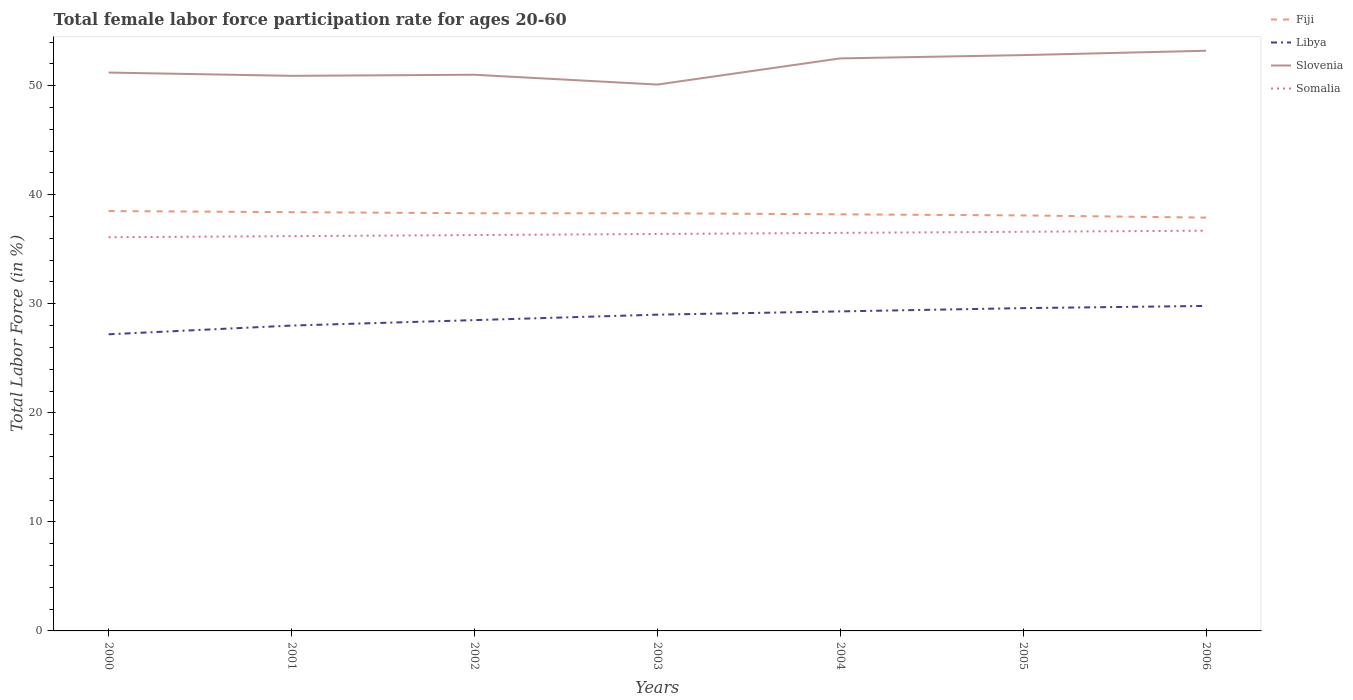How many different coloured lines are there?
Your answer should be compact. 4. Is the number of lines equal to the number of legend labels?
Make the answer very short. Yes. Across all years, what is the maximum female labor force participation rate in Slovenia?
Keep it short and to the point. 50.1. What is the total female labor force participation rate in Libya in the graph?
Give a very brief answer. -1.1. What is the difference between the highest and the second highest female labor force participation rate in Slovenia?
Give a very brief answer. 3.1. What is the difference between the highest and the lowest female labor force participation rate in Slovenia?
Give a very brief answer. 3. Is the female labor force participation rate in Fiji strictly greater than the female labor force participation rate in Somalia over the years?
Your answer should be compact. No. How many lines are there?
Make the answer very short. 4. What is the difference between two consecutive major ticks on the Y-axis?
Offer a very short reply. 10. Are the values on the major ticks of Y-axis written in scientific E-notation?
Your answer should be very brief. No. Does the graph contain any zero values?
Your response must be concise. No. Does the graph contain grids?
Make the answer very short. No. Where does the legend appear in the graph?
Your answer should be very brief. Top right. How are the legend labels stacked?
Give a very brief answer. Vertical. What is the title of the graph?
Give a very brief answer. Total female labor force participation rate for ages 20-60. Does "Aruba" appear as one of the legend labels in the graph?
Your answer should be compact. No. What is the label or title of the Y-axis?
Your answer should be compact. Total Labor Force (in %). What is the Total Labor Force (in %) of Fiji in 2000?
Offer a terse response. 38.5. What is the Total Labor Force (in %) of Libya in 2000?
Keep it short and to the point. 27.2. What is the Total Labor Force (in %) of Slovenia in 2000?
Ensure brevity in your answer.  51.2. What is the Total Labor Force (in %) in Somalia in 2000?
Your response must be concise. 36.1. What is the Total Labor Force (in %) in Fiji in 2001?
Offer a very short reply. 38.4. What is the Total Labor Force (in %) of Libya in 2001?
Offer a terse response. 28. What is the Total Labor Force (in %) in Slovenia in 2001?
Give a very brief answer. 50.9. What is the Total Labor Force (in %) of Somalia in 2001?
Your response must be concise. 36.2. What is the Total Labor Force (in %) of Fiji in 2002?
Keep it short and to the point. 38.3. What is the Total Labor Force (in %) in Libya in 2002?
Ensure brevity in your answer.  28.5. What is the Total Labor Force (in %) in Slovenia in 2002?
Your answer should be very brief. 51. What is the Total Labor Force (in %) in Somalia in 2002?
Ensure brevity in your answer.  36.3. What is the Total Labor Force (in %) of Fiji in 2003?
Ensure brevity in your answer.  38.3. What is the Total Labor Force (in %) of Slovenia in 2003?
Ensure brevity in your answer.  50.1. What is the Total Labor Force (in %) in Somalia in 2003?
Give a very brief answer. 36.4. What is the Total Labor Force (in %) in Fiji in 2004?
Make the answer very short. 38.2. What is the Total Labor Force (in %) in Libya in 2004?
Your answer should be compact. 29.3. What is the Total Labor Force (in %) of Slovenia in 2004?
Make the answer very short. 52.5. What is the Total Labor Force (in %) in Somalia in 2004?
Make the answer very short. 36.5. What is the Total Labor Force (in %) of Fiji in 2005?
Your answer should be compact. 38.1. What is the Total Labor Force (in %) of Libya in 2005?
Provide a succinct answer. 29.6. What is the Total Labor Force (in %) of Slovenia in 2005?
Keep it short and to the point. 52.8. What is the Total Labor Force (in %) in Somalia in 2005?
Your response must be concise. 36.6. What is the Total Labor Force (in %) in Fiji in 2006?
Keep it short and to the point. 37.9. What is the Total Labor Force (in %) of Libya in 2006?
Keep it short and to the point. 29.8. What is the Total Labor Force (in %) of Slovenia in 2006?
Your response must be concise. 53.2. What is the Total Labor Force (in %) in Somalia in 2006?
Keep it short and to the point. 36.7. Across all years, what is the maximum Total Labor Force (in %) of Fiji?
Provide a short and direct response. 38.5. Across all years, what is the maximum Total Labor Force (in %) in Libya?
Provide a short and direct response. 29.8. Across all years, what is the maximum Total Labor Force (in %) in Slovenia?
Provide a short and direct response. 53.2. Across all years, what is the maximum Total Labor Force (in %) in Somalia?
Keep it short and to the point. 36.7. Across all years, what is the minimum Total Labor Force (in %) of Fiji?
Your answer should be compact. 37.9. Across all years, what is the minimum Total Labor Force (in %) of Libya?
Give a very brief answer. 27.2. Across all years, what is the minimum Total Labor Force (in %) of Slovenia?
Make the answer very short. 50.1. Across all years, what is the minimum Total Labor Force (in %) of Somalia?
Your response must be concise. 36.1. What is the total Total Labor Force (in %) in Fiji in the graph?
Provide a succinct answer. 267.7. What is the total Total Labor Force (in %) in Libya in the graph?
Keep it short and to the point. 201.4. What is the total Total Labor Force (in %) in Slovenia in the graph?
Offer a very short reply. 361.7. What is the total Total Labor Force (in %) in Somalia in the graph?
Keep it short and to the point. 254.8. What is the difference between the Total Labor Force (in %) of Fiji in 2000 and that in 2002?
Provide a succinct answer. 0.2. What is the difference between the Total Labor Force (in %) of Libya in 2000 and that in 2002?
Your answer should be compact. -1.3. What is the difference between the Total Labor Force (in %) of Slovenia in 2000 and that in 2002?
Keep it short and to the point. 0.2. What is the difference between the Total Labor Force (in %) in Fiji in 2000 and that in 2004?
Make the answer very short. 0.3. What is the difference between the Total Labor Force (in %) in Somalia in 2000 and that in 2004?
Ensure brevity in your answer.  -0.4. What is the difference between the Total Labor Force (in %) of Fiji in 2000 and that in 2006?
Give a very brief answer. 0.6. What is the difference between the Total Labor Force (in %) of Slovenia in 2000 and that in 2006?
Ensure brevity in your answer.  -2. What is the difference between the Total Labor Force (in %) in Somalia in 2000 and that in 2006?
Offer a very short reply. -0.6. What is the difference between the Total Labor Force (in %) of Libya in 2001 and that in 2002?
Your answer should be compact. -0.5. What is the difference between the Total Labor Force (in %) in Slovenia in 2001 and that in 2002?
Make the answer very short. -0.1. What is the difference between the Total Labor Force (in %) in Somalia in 2001 and that in 2002?
Your answer should be very brief. -0.1. What is the difference between the Total Labor Force (in %) of Libya in 2001 and that in 2003?
Provide a short and direct response. -1. What is the difference between the Total Labor Force (in %) of Fiji in 2001 and that in 2004?
Your answer should be compact. 0.2. What is the difference between the Total Labor Force (in %) of Slovenia in 2001 and that in 2004?
Your response must be concise. -1.6. What is the difference between the Total Labor Force (in %) of Fiji in 2001 and that in 2005?
Offer a terse response. 0.3. What is the difference between the Total Labor Force (in %) of Libya in 2001 and that in 2005?
Your answer should be compact. -1.6. What is the difference between the Total Labor Force (in %) of Fiji in 2001 and that in 2006?
Your answer should be very brief. 0.5. What is the difference between the Total Labor Force (in %) of Libya in 2001 and that in 2006?
Give a very brief answer. -1.8. What is the difference between the Total Labor Force (in %) of Slovenia in 2001 and that in 2006?
Ensure brevity in your answer.  -2.3. What is the difference between the Total Labor Force (in %) of Fiji in 2002 and that in 2003?
Your answer should be compact. 0. What is the difference between the Total Labor Force (in %) in Slovenia in 2002 and that in 2003?
Ensure brevity in your answer.  0.9. What is the difference between the Total Labor Force (in %) of Somalia in 2002 and that in 2003?
Your answer should be compact. -0.1. What is the difference between the Total Labor Force (in %) in Fiji in 2002 and that in 2004?
Ensure brevity in your answer.  0.1. What is the difference between the Total Labor Force (in %) in Slovenia in 2002 and that in 2004?
Offer a terse response. -1.5. What is the difference between the Total Labor Force (in %) of Libya in 2002 and that in 2005?
Provide a succinct answer. -1.1. What is the difference between the Total Labor Force (in %) of Somalia in 2002 and that in 2005?
Provide a succinct answer. -0.3. What is the difference between the Total Labor Force (in %) in Fiji in 2002 and that in 2006?
Give a very brief answer. 0.4. What is the difference between the Total Labor Force (in %) in Libya in 2002 and that in 2006?
Provide a short and direct response. -1.3. What is the difference between the Total Labor Force (in %) in Somalia in 2002 and that in 2006?
Offer a terse response. -0.4. What is the difference between the Total Labor Force (in %) of Fiji in 2003 and that in 2004?
Your answer should be compact. 0.1. What is the difference between the Total Labor Force (in %) in Libya in 2003 and that in 2004?
Your answer should be compact. -0.3. What is the difference between the Total Labor Force (in %) in Slovenia in 2003 and that in 2005?
Offer a terse response. -2.7. What is the difference between the Total Labor Force (in %) of Somalia in 2003 and that in 2005?
Keep it short and to the point. -0.2. What is the difference between the Total Labor Force (in %) of Fiji in 2003 and that in 2006?
Provide a succinct answer. 0.4. What is the difference between the Total Labor Force (in %) in Libya in 2003 and that in 2006?
Offer a terse response. -0.8. What is the difference between the Total Labor Force (in %) in Slovenia in 2003 and that in 2006?
Give a very brief answer. -3.1. What is the difference between the Total Labor Force (in %) in Fiji in 2004 and that in 2006?
Keep it short and to the point. 0.3. What is the difference between the Total Labor Force (in %) of Slovenia in 2004 and that in 2006?
Offer a very short reply. -0.7. What is the difference between the Total Labor Force (in %) in Somalia in 2004 and that in 2006?
Provide a short and direct response. -0.2. What is the difference between the Total Labor Force (in %) in Libya in 2005 and that in 2006?
Your answer should be very brief. -0.2. What is the difference between the Total Labor Force (in %) in Slovenia in 2005 and that in 2006?
Offer a very short reply. -0.4. What is the difference between the Total Labor Force (in %) in Fiji in 2000 and the Total Labor Force (in %) in Slovenia in 2001?
Keep it short and to the point. -12.4. What is the difference between the Total Labor Force (in %) in Libya in 2000 and the Total Labor Force (in %) in Slovenia in 2001?
Give a very brief answer. -23.7. What is the difference between the Total Labor Force (in %) of Fiji in 2000 and the Total Labor Force (in %) of Libya in 2002?
Your response must be concise. 10. What is the difference between the Total Labor Force (in %) in Fiji in 2000 and the Total Labor Force (in %) in Slovenia in 2002?
Ensure brevity in your answer.  -12.5. What is the difference between the Total Labor Force (in %) of Libya in 2000 and the Total Labor Force (in %) of Slovenia in 2002?
Offer a terse response. -23.8. What is the difference between the Total Labor Force (in %) of Libya in 2000 and the Total Labor Force (in %) of Somalia in 2002?
Your answer should be compact. -9.1. What is the difference between the Total Labor Force (in %) in Slovenia in 2000 and the Total Labor Force (in %) in Somalia in 2002?
Ensure brevity in your answer.  14.9. What is the difference between the Total Labor Force (in %) of Fiji in 2000 and the Total Labor Force (in %) of Libya in 2003?
Provide a short and direct response. 9.5. What is the difference between the Total Labor Force (in %) in Fiji in 2000 and the Total Labor Force (in %) in Slovenia in 2003?
Your answer should be very brief. -11.6. What is the difference between the Total Labor Force (in %) of Fiji in 2000 and the Total Labor Force (in %) of Somalia in 2003?
Make the answer very short. 2.1. What is the difference between the Total Labor Force (in %) of Libya in 2000 and the Total Labor Force (in %) of Slovenia in 2003?
Make the answer very short. -22.9. What is the difference between the Total Labor Force (in %) in Fiji in 2000 and the Total Labor Force (in %) in Libya in 2004?
Ensure brevity in your answer.  9.2. What is the difference between the Total Labor Force (in %) in Fiji in 2000 and the Total Labor Force (in %) in Somalia in 2004?
Ensure brevity in your answer.  2. What is the difference between the Total Labor Force (in %) of Libya in 2000 and the Total Labor Force (in %) of Slovenia in 2004?
Keep it short and to the point. -25.3. What is the difference between the Total Labor Force (in %) in Libya in 2000 and the Total Labor Force (in %) in Somalia in 2004?
Ensure brevity in your answer.  -9.3. What is the difference between the Total Labor Force (in %) in Fiji in 2000 and the Total Labor Force (in %) in Slovenia in 2005?
Keep it short and to the point. -14.3. What is the difference between the Total Labor Force (in %) in Fiji in 2000 and the Total Labor Force (in %) in Somalia in 2005?
Offer a very short reply. 1.9. What is the difference between the Total Labor Force (in %) in Libya in 2000 and the Total Labor Force (in %) in Slovenia in 2005?
Give a very brief answer. -25.6. What is the difference between the Total Labor Force (in %) in Libya in 2000 and the Total Labor Force (in %) in Somalia in 2005?
Ensure brevity in your answer.  -9.4. What is the difference between the Total Labor Force (in %) in Fiji in 2000 and the Total Labor Force (in %) in Libya in 2006?
Offer a terse response. 8.7. What is the difference between the Total Labor Force (in %) of Fiji in 2000 and the Total Labor Force (in %) of Slovenia in 2006?
Offer a terse response. -14.7. What is the difference between the Total Labor Force (in %) in Fiji in 2000 and the Total Labor Force (in %) in Somalia in 2006?
Make the answer very short. 1.8. What is the difference between the Total Labor Force (in %) in Slovenia in 2000 and the Total Labor Force (in %) in Somalia in 2006?
Offer a terse response. 14.5. What is the difference between the Total Labor Force (in %) in Fiji in 2001 and the Total Labor Force (in %) in Libya in 2002?
Your response must be concise. 9.9. What is the difference between the Total Labor Force (in %) of Fiji in 2001 and the Total Labor Force (in %) of Slovenia in 2002?
Give a very brief answer. -12.6. What is the difference between the Total Labor Force (in %) in Fiji in 2001 and the Total Labor Force (in %) in Somalia in 2002?
Your answer should be compact. 2.1. What is the difference between the Total Labor Force (in %) of Libya in 2001 and the Total Labor Force (in %) of Slovenia in 2002?
Offer a terse response. -23. What is the difference between the Total Labor Force (in %) in Libya in 2001 and the Total Labor Force (in %) in Somalia in 2002?
Ensure brevity in your answer.  -8.3. What is the difference between the Total Labor Force (in %) of Fiji in 2001 and the Total Labor Force (in %) of Slovenia in 2003?
Provide a succinct answer. -11.7. What is the difference between the Total Labor Force (in %) of Libya in 2001 and the Total Labor Force (in %) of Slovenia in 2003?
Your answer should be very brief. -22.1. What is the difference between the Total Labor Force (in %) in Fiji in 2001 and the Total Labor Force (in %) in Slovenia in 2004?
Provide a succinct answer. -14.1. What is the difference between the Total Labor Force (in %) of Libya in 2001 and the Total Labor Force (in %) of Slovenia in 2004?
Provide a succinct answer. -24.5. What is the difference between the Total Labor Force (in %) of Slovenia in 2001 and the Total Labor Force (in %) of Somalia in 2004?
Your answer should be very brief. 14.4. What is the difference between the Total Labor Force (in %) in Fiji in 2001 and the Total Labor Force (in %) in Slovenia in 2005?
Ensure brevity in your answer.  -14.4. What is the difference between the Total Labor Force (in %) of Fiji in 2001 and the Total Labor Force (in %) of Somalia in 2005?
Offer a terse response. 1.8. What is the difference between the Total Labor Force (in %) of Libya in 2001 and the Total Labor Force (in %) of Slovenia in 2005?
Your response must be concise. -24.8. What is the difference between the Total Labor Force (in %) in Libya in 2001 and the Total Labor Force (in %) in Somalia in 2005?
Provide a short and direct response. -8.6. What is the difference between the Total Labor Force (in %) in Fiji in 2001 and the Total Labor Force (in %) in Slovenia in 2006?
Your answer should be compact. -14.8. What is the difference between the Total Labor Force (in %) in Fiji in 2001 and the Total Labor Force (in %) in Somalia in 2006?
Keep it short and to the point. 1.7. What is the difference between the Total Labor Force (in %) in Libya in 2001 and the Total Labor Force (in %) in Slovenia in 2006?
Give a very brief answer. -25.2. What is the difference between the Total Labor Force (in %) in Slovenia in 2001 and the Total Labor Force (in %) in Somalia in 2006?
Ensure brevity in your answer.  14.2. What is the difference between the Total Labor Force (in %) in Fiji in 2002 and the Total Labor Force (in %) in Somalia in 2003?
Ensure brevity in your answer.  1.9. What is the difference between the Total Labor Force (in %) in Libya in 2002 and the Total Labor Force (in %) in Slovenia in 2003?
Provide a succinct answer. -21.6. What is the difference between the Total Labor Force (in %) in Fiji in 2002 and the Total Labor Force (in %) in Slovenia in 2004?
Your answer should be very brief. -14.2. What is the difference between the Total Labor Force (in %) in Slovenia in 2002 and the Total Labor Force (in %) in Somalia in 2004?
Provide a short and direct response. 14.5. What is the difference between the Total Labor Force (in %) in Fiji in 2002 and the Total Labor Force (in %) in Libya in 2005?
Your response must be concise. 8.7. What is the difference between the Total Labor Force (in %) in Fiji in 2002 and the Total Labor Force (in %) in Somalia in 2005?
Make the answer very short. 1.7. What is the difference between the Total Labor Force (in %) in Libya in 2002 and the Total Labor Force (in %) in Slovenia in 2005?
Offer a very short reply. -24.3. What is the difference between the Total Labor Force (in %) in Slovenia in 2002 and the Total Labor Force (in %) in Somalia in 2005?
Keep it short and to the point. 14.4. What is the difference between the Total Labor Force (in %) of Fiji in 2002 and the Total Labor Force (in %) of Libya in 2006?
Offer a very short reply. 8.5. What is the difference between the Total Labor Force (in %) in Fiji in 2002 and the Total Labor Force (in %) in Slovenia in 2006?
Your response must be concise. -14.9. What is the difference between the Total Labor Force (in %) of Fiji in 2002 and the Total Labor Force (in %) of Somalia in 2006?
Your answer should be compact. 1.6. What is the difference between the Total Labor Force (in %) in Libya in 2002 and the Total Labor Force (in %) in Slovenia in 2006?
Your answer should be very brief. -24.7. What is the difference between the Total Labor Force (in %) of Libya in 2002 and the Total Labor Force (in %) of Somalia in 2006?
Provide a succinct answer. -8.2. What is the difference between the Total Labor Force (in %) in Fiji in 2003 and the Total Labor Force (in %) in Libya in 2004?
Your answer should be compact. 9. What is the difference between the Total Labor Force (in %) in Fiji in 2003 and the Total Labor Force (in %) in Slovenia in 2004?
Provide a succinct answer. -14.2. What is the difference between the Total Labor Force (in %) of Libya in 2003 and the Total Labor Force (in %) of Slovenia in 2004?
Provide a short and direct response. -23.5. What is the difference between the Total Labor Force (in %) in Slovenia in 2003 and the Total Labor Force (in %) in Somalia in 2004?
Your answer should be compact. 13.6. What is the difference between the Total Labor Force (in %) in Fiji in 2003 and the Total Labor Force (in %) in Slovenia in 2005?
Your answer should be compact. -14.5. What is the difference between the Total Labor Force (in %) of Fiji in 2003 and the Total Labor Force (in %) of Somalia in 2005?
Your answer should be compact. 1.7. What is the difference between the Total Labor Force (in %) in Libya in 2003 and the Total Labor Force (in %) in Slovenia in 2005?
Provide a short and direct response. -23.8. What is the difference between the Total Labor Force (in %) in Libya in 2003 and the Total Labor Force (in %) in Somalia in 2005?
Offer a very short reply. -7.6. What is the difference between the Total Labor Force (in %) in Slovenia in 2003 and the Total Labor Force (in %) in Somalia in 2005?
Provide a succinct answer. 13.5. What is the difference between the Total Labor Force (in %) in Fiji in 2003 and the Total Labor Force (in %) in Libya in 2006?
Your answer should be compact. 8.5. What is the difference between the Total Labor Force (in %) in Fiji in 2003 and the Total Labor Force (in %) in Slovenia in 2006?
Provide a succinct answer. -14.9. What is the difference between the Total Labor Force (in %) of Libya in 2003 and the Total Labor Force (in %) of Slovenia in 2006?
Keep it short and to the point. -24.2. What is the difference between the Total Labor Force (in %) of Fiji in 2004 and the Total Labor Force (in %) of Slovenia in 2005?
Make the answer very short. -14.6. What is the difference between the Total Labor Force (in %) of Fiji in 2004 and the Total Labor Force (in %) of Somalia in 2005?
Provide a short and direct response. 1.6. What is the difference between the Total Labor Force (in %) in Libya in 2004 and the Total Labor Force (in %) in Slovenia in 2005?
Make the answer very short. -23.5. What is the difference between the Total Labor Force (in %) of Libya in 2004 and the Total Labor Force (in %) of Somalia in 2005?
Your response must be concise. -7.3. What is the difference between the Total Labor Force (in %) in Slovenia in 2004 and the Total Labor Force (in %) in Somalia in 2005?
Offer a very short reply. 15.9. What is the difference between the Total Labor Force (in %) of Libya in 2004 and the Total Labor Force (in %) of Slovenia in 2006?
Offer a very short reply. -23.9. What is the difference between the Total Labor Force (in %) of Fiji in 2005 and the Total Labor Force (in %) of Slovenia in 2006?
Your answer should be very brief. -15.1. What is the difference between the Total Labor Force (in %) of Fiji in 2005 and the Total Labor Force (in %) of Somalia in 2006?
Your answer should be compact. 1.4. What is the difference between the Total Labor Force (in %) of Libya in 2005 and the Total Labor Force (in %) of Slovenia in 2006?
Keep it short and to the point. -23.6. What is the difference between the Total Labor Force (in %) of Slovenia in 2005 and the Total Labor Force (in %) of Somalia in 2006?
Offer a terse response. 16.1. What is the average Total Labor Force (in %) of Fiji per year?
Provide a short and direct response. 38.24. What is the average Total Labor Force (in %) of Libya per year?
Offer a terse response. 28.77. What is the average Total Labor Force (in %) in Slovenia per year?
Offer a terse response. 51.67. What is the average Total Labor Force (in %) in Somalia per year?
Give a very brief answer. 36.4. In the year 2000, what is the difference between the Total Labor Force (in %) in Fiji and Total Labor Force (in %) in Libya?
Offer a very short reply. 11.3. In the year 2000, what is the difference between the Total Labor Force (in %) in Libya and Total Labor Force (in %) in Slovenia?
Give a very brief answer. -24. In the year 2000, what is the difference between the Total Labor Force (in %) of Libya and Total Labor Force (in %) of Somalia?
Provide a succinct answer. -8.9. In the year 2001, what is the difference between the Total Labor Force (in %) in Fiji and Total Labor Force (in %) in Slovenia?
Keep it short and to the point. -12.5. In the year 2001, what is the difference between the Total Labor Force (in %) in Libya and Total Labor Force (in %) in Slovenia?
Keep it short and to the point. -22.9. In the year 2001, what is the difference between the Total Labor Force (in %) of Libya and Total Labor Force (in %) of Somalia?
Provide a short and direct response. -8.2. In the year 2001, what is the difference between the Total Labor Force (in %) in Slovenia and Total Labor Force (in %) in Somalia?
Provide a short and direct response. 14.7. In the year 2002, what is the difference between the Total Labor Force (in %) in Fiji and Total Labor Force (in %) in Slovenia?
Offer a very short reply. -12.7. In the year 2002, what is the difference between the Total Labor Force (in %) of Fiji and Total Labor Force (in %) of Somalia?
Give a very brief answer. 2. In the year 2002, what is the difference between the Total Labor Force (in %) of Libya and Total Labor Force (in %) of Slovenia?
Your answer should be compact. -22.5. In the year 2002, what is the difference between the Total Labor Force (in %) of Libya and Total Labor Force (in %) of Somalia?
Keep it short and to the point. -7.8. In the year 2003, what is the difference between the Total Labor Force (in %) in Fiji and Total Labor Force (in %) in Libya?
Your answer should be very brief. 9.3. In the year 2003, what is the difference between the Total Labor Force (in %) in Libya and Total Labor Force (in %) in Slovenia?
Your response must be concise. -21.1. In the year 2003, what is the difference between the Total Labor Force (in %) in Libya and Total Labor Force (in %) in Somalia?
Ensure brevity in your answer.  -7.4. In the year 2004, what is the difference between the Total Labor Force (in %) in Fiji and Total Labor Force (in %) in Libya?
Your answer should be very brief. 8.9. In the year 2004, what is the difference between the Total Labor Force (in %) in Fiji and Total Labor Force (in %) in Slovenia?
Provide a succinct answer. -14.3. In the year 2004, what is the difference between the Total Labor Force (in %) in Libya and Total Labor Force (in %) in Slovenia?
Your answer should be compact. -23.2. In the year 2004, what is the difference between the Total Labor Force (in %) in Slovenia and Total Labor Force (in %) in Somalia?
Keep it short and to the point. 16. In the year 2005, what is the difference between the Total Labor Force (in %) of Fiji and Total Labor Force (in %) of Libya?
Provide a short and direct response. 8.5. In the year 2005, what is the difference between the Total Labor Force (in %) in Fiji and Total Labor Force (in %) in Slovenia?
Ensure brevity in your answer.  -14.7. In the year 2005, what is the difference between the Total Labor Force (in %) in Fiji and Total Labor Force (in %) in Somalia?
Ensure brevity in your answer.  1.5. In the year 2005, what is the difference between the Total Labor Force (in %) in Libya and Total Labor Force (in %) in Slovenia?
Offer a very short reply. -23.2. In the year 2006, what is the difference between the Total Labor Force (in %) of Fiji and Total Labor Force (in %) of Libya?
Your answer should be compact. 8.1. In the year 2006, what is the difference between the Total Labor Force (in %) of Fiji and Total Labor Force (in %) of Slovenia?
Provide a succinct answer. -15.3. In the year 2006, what is the difference between the Total Labor Force (in %) of Libya and Total Labor Force (in %) of Slovenia?
Offer a very short reply. -23.4. What is the ratio of the Total Labor Force (in %) in Libya in 2000 to that in 2001?
Your answer should be very brief. 0.97. What is the ratio of the Total Labor Force (in %) in Slovenia in 2000 to that in 2001?
Your answer should be compact. 1.01. What is the ratio of the Total Labor Force (in %) of Somalia in 2000 to that in 2001?
Make the answer very short. 1. What is the ratio of the Total Labor Force (in %) of Libya in 2000 to that in 2002?
Your response must be concise. 0.95. What is the ratio of the Total Labor Force (in %) in Slovenia in 2000 to that in 2002?
Make the answer very short. 1. What is the ratio of the Total Labor Force (in %) of Fiji in 2000 to that in 2003?
Keep it short and to the point. 1.01. What is the ratio of the Total Labor Force (in %) of Libya in 2000 to that in 2003?
Keep it short and to the point. 0.94. What is the ratio of the Total Labor Force (in %) in Fiji in 2000 to that in 2004?
Your answer should be compact. 1.01. What is the ratio of the Total Labor Force (in %) of Libya in 2000 to that in 2004?
Your answer should be compact. 0.93. What is the ratio of the Total Labor Force (in %) in Slovenia in 2000 to that in 2004?
Ensure brevity in your answer.  0.98. What is the ratio of the Total Labor Force (in %) in Fiji in 2000 to that in 2005?
Ensure brevity in your answer.  1.01. What is the ratio of the Total Labor Force (in %) in Libya in 2000 to that in 2005?
Ensure brevity in your answer.  0.92. What is the ratio of the Total Labor Force (in %) in Slovenia in 2000 to that in 2005?
Give a very brief answer. 0.97. What is the ratio of the Total Labor Force (in %) in Somalia in 2000 to that in 2005?
Keep it short and to the point. 0.99. What is the ratio of the Total Labor Force (in %) of Fiji in 2000 to that in 2006?
Give a very brief answer. 1.02. What is the ratio of the Total Labor Force (in %) in Libya in 2000 to that in 2006?
Your answer should be compact. 0.91. What is the ratio of the Total Labor Force (in %) of Slovenia in 2000 to that in 2006?
Ensure brevity in your answer.  0.96. What is the ratio of the Total Labor Force (in %) in Somalia in 2000 to that in 2006?
Provide a short and direct response. 0.98. What is the ratio of the Total Labor Force (in %) of Libya in 2001 to that in 2002?
Offer a terse response. 0.98. What is the ratio of the Total Labor Force (in %) of Somalia in 2001 to that in 2002?
Offer a very short reply. 1. What is the ratio of the Total Labor Force (in %) of Libya in 2001 to that in 2003?
Offer a very short reply. 0.97. What is the ratio of the Total Labor Force (in %) of Somalia in 2001 to that in 2003?
Keep it short and to the point. 0.99. What is the ratio of the Total Labor Force (in %) of Libya in 2001 to that in 2004?
Your answer should be very brief. 0.96. What is the ratio of the Total Labor Force (in %) of Slovenia in 2001 to that in 2004?
Your answer should be compact. 0.97. What is the ratio of the Total Labor Force (in %) in Somalia in 2001 to that in 2004?
Ensure brevity in your answer.  0.99. What is the ratio of the Total Labor Force (in %) of Fiji in 2001 to that in 2005?
Offer a terse response. 1.01. What is the ratio of the Total Labor Force (in %) of Libya in 2001 to that in 2005?
Offer a terse response. 0.95. What is the ratio of the Total Labor Force (in %) of Fiji in 2001 to that in 2006?
Offer a very short reply. 1.01. What is the ratio of the Total Labor Force (in %) in Libya in 2001 to that in 2006?
Provide a short and direct response. 0.94. What is the ratio of the Total Labor Force (in %) of Slovenia in 2001 to that in 2006?
Give a very brief answer. 0.96. What is the ratio of the Total Labor Force (in %) of Somalia in 2001 to that in 2006?
Make the answer very short. 0.99. What is the ratio of the Total Labor Force (in %) of Fiji in 2002 to that in 2003?
Provide a short and direct response. 1. What is the ratio of the Total Labor Force (in %) in Libya in 2002 to that in 2003?
Provide a short and direct response. 0.98. What is the ratio of the Total Labor Force (in %) in Fiji in 2002 to that in 2004?
Offer a very short reply. 1. What is the ratio of the Total Labor Force (in %) in Libya in 2002 to that in 2004?
Offer a terse response. 0.97. What is the ratio of the Total Labor Force (in %) in Slovenia in 2002 to that in 2004?
Make the answer very short. 0.97. What is the ratio of the Total Labor Force (in %) of Somalia in 2002 to that in 2004?
Provide a succinct answer. 0.99. What is the ratio of the Total Labor Force (in %) of Libya in 2002 to that in 2005?
Ensure brevity in your answer.  0.96. What is the ratio of the Total Labor Force (in %) in Slovenia in 2002 to that in 2005?
Offer a very short reply. 0.97. What is the ratio of the Total Labor Force (in %) of Fiji in 2002 to that in 2006?
Ensure brevity in your answer.  1.01. What is the ratio of the Total Labor Force (in %) in Libya in 2002 to that in 2006?
Offer a terse response. 0.96. What is the ratio of the Total Labor Force (in %) in Slovenia in 2002 to that in 2006?
Provide a succinct answer. 0.96. What is the ratio of the Total Labor Force (in %) in Fiji in 2003 to that in 2004?
Give a very brief answer. 1. What is the ratio of the Total Labor Force (in %) in Slovenia in 2003 to that in 2004?
Your answer should be very brief. 0.95. What is the ratio of the Total Labor Force (in %) in Somalia in 2003 to that in 2004?
Offer a terse response. 1. What is the ratio of the Total Labor Force (in %) of Libya in 2003 to that in 2005?
Your response must be concise. 0.98. What is the ratio of the Total Labor Force (in %) of Slovenia in 2003 to that in 2005?
Provide a succinct answer. 0.95. What is the ratio of the Total Labor Force (in %) in Fiji in 2003 to that in 2006?
Your answer should be compact. 1.01. What is the ratio of the Total Labor Force (in %) in Libya in 2003 to that in 2006?
Give a very brief answer. 0.97. What is the ratio of the Total Labor Force (in %) of Slovenia in 2003 to that in 2006?
Ensure brevity in your answer.  0.94. What is the ratio of the Total Labor Force (in %) in Fiji in 2004 to that in 2005?
Offer a terse response. 1. What is the ratio of the Total Labor Force (in %) of Libya in 2004 to that in 2005?
Keep it short and to the point. 0.99. What is the ratio of the Total Labor Force (in %) of Somalia in 2004 to that in 2005?
Ensure brevity in your answer.  1. What is the ratio of the Total Labor Force (in %) of Fiji in 2004 to that in 2006?
Offer a terse response. 1.01. What is the ratio of the Total Labor Force (in %) of Libya in 2004 to that in 2006?
Provide a short and direct response. 0.98. What is the ratio of the Total Labor Force (in %) in Slovenia in 2004 to that in 2006?
Give a very brief answer. 0.99. What is the ratio of the Total Labor Force (in %) in Somalia in 2004 to that in 2006?
Offer a terse response. 0.99. What is the ratio of the Total Labor Force (in %) in Slovenia in 2005 to that in 2006?
Give a very brief answer. 0.99. What is the ratio of the Total Labor Force (in %) in Somalia in 2005 to that in 2006?
Provide a short and direct response. 1. What is the difference between the highest and the second highest Total Labor Force (in %) in Somalia?
Offer a terse response. 0.1. What is the difference between the highest and the lowest Total Labor Force (in %) in Fiji?
Ensure brevity in your answer.  0.6. What is the difference between the highest and the lowest Total Labor Force (in %) of Slovenia?
Your response must be concise. 3.1. What is the difference between the highest and the lowest Total Labor Force (in %) of Somalia?
Offer a terse response. 0.6. 